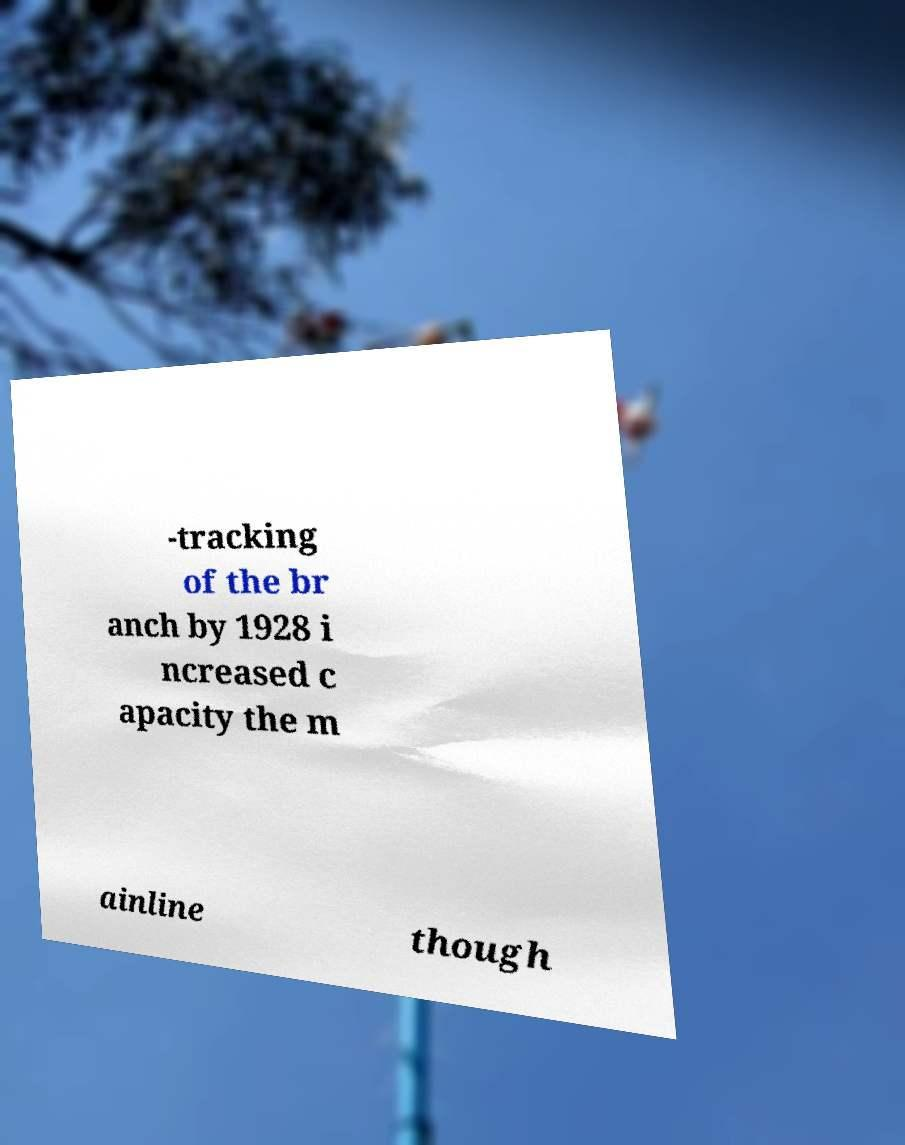Can you read and provide the text displayed in the image?This photo seems to have some interesting text. Can you extract and type it out for me? -tracking of the br anch by 1928 i ncreased c apacity the m ainline though 